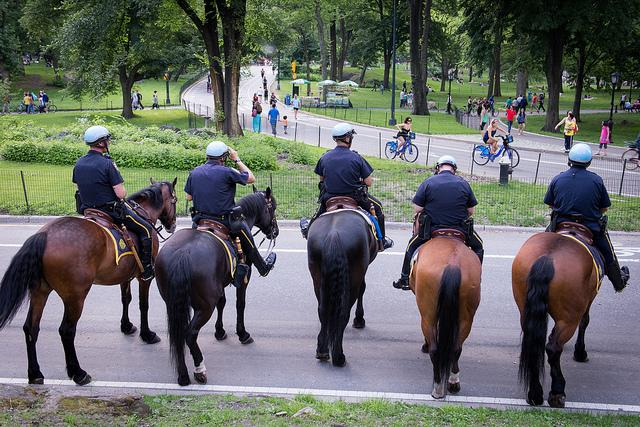What setting do these mounted persons stand in?

Choices:
A) park
B) riot
C) mall
D) grocery store park 